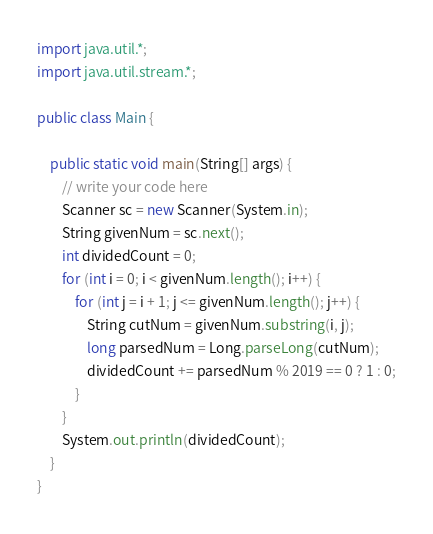Convert code to text. <code><loc_0><loc_0><loc_500><loc_500><_Java_>import java.util.*;
import java.util.stream.*;

public class Main {

    public static void main(String[] args) {
	    // write your code here
        Scanner sc = new Scanner(System.in);
        String givenNum = sc.next();
        int dividedCount = 0;
        for (int i = 0; i < givenNum.length(); i++) {
            for (int j = i + 1; j <= givenNum.length(); j++) {
                String cutNum = givenNum.substring(i, j);
                long parsedNum = Long.parseLong(cutNum);
                dividedCount += parsedNum % 2019 == 0 ? 1 : 0;
            }
        }
        System.out.println(dividedCount);
    }
}
</code> 